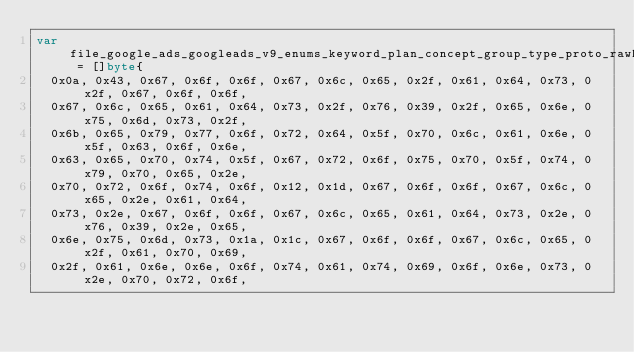Convert code to text. <code><loc_0><loc_0><loc_500><loc_500><_Go_>var file_google_ads_googleads_v9_enums_keyword_plan_concept_group_type_proto_rawDesc = []byte{
	0x0a, 0x43, 0x67, 0x6f, 0x6f, 0x67, 0x6c, 0x65, 0x2f, 0x61, 0x64, 0x73, 0x2f, 0x67, 0x6f, 0x6f,
	0x67, 0x6c, 0x65, 0x61, 0x64, 0x73, 0x2f, 0x76, 0x39, 0x2f, 0x65, 0x6e, 0x75, 0x6d, 0x73, 0x2f,
	0x6b, 0x65, 0x79, 0x77, 0x6f, 0x72, 0x64, 0x5f, 0x70, 0x6c, 0x61, 0x6e, 0x5f, 0x63, 0x6f, 0x6e,
	0x63, 0x65, 0x70, 0x74, 0x5f, 0x67, 0x72, 0x6f, 0x75, 0x70, 0x5f, 0x74, 0x79, 0x70, 0x65, 0x2e,
	0x70, 0x72, 0x6f, 0x74, 0x6f, 0x12, 0x1d, 0x67, 0x6f, 0x6f, 0x67, 0x6c, 0x65, 0x2e, 0x61, 0x64,
	0x73, 0x2e, 0x67, 0x6f, 0x6f, 0x67, 0x6c, 0x65, 0x61, 0x64, 0x73, 0x2e, 0x76, 0x39, 0x2e, 0x65,
	0x6e, 0x75, 0x6d, 0x73, 0x1a, 0x1c, 0x67, 0x6f, 0x6f, 0x67, 0x6c, 0x65, 0x2f, 0x61, 0x70, 0x69,
	0x2f, 0x61, 0x6e, 0x6e, 0x6f, 0x74, 0x61, 0x74, 0x69, 0x6f, 0x6e, 0x73, 0x2e, 0x70, 0x72, 0x6f,</code> 